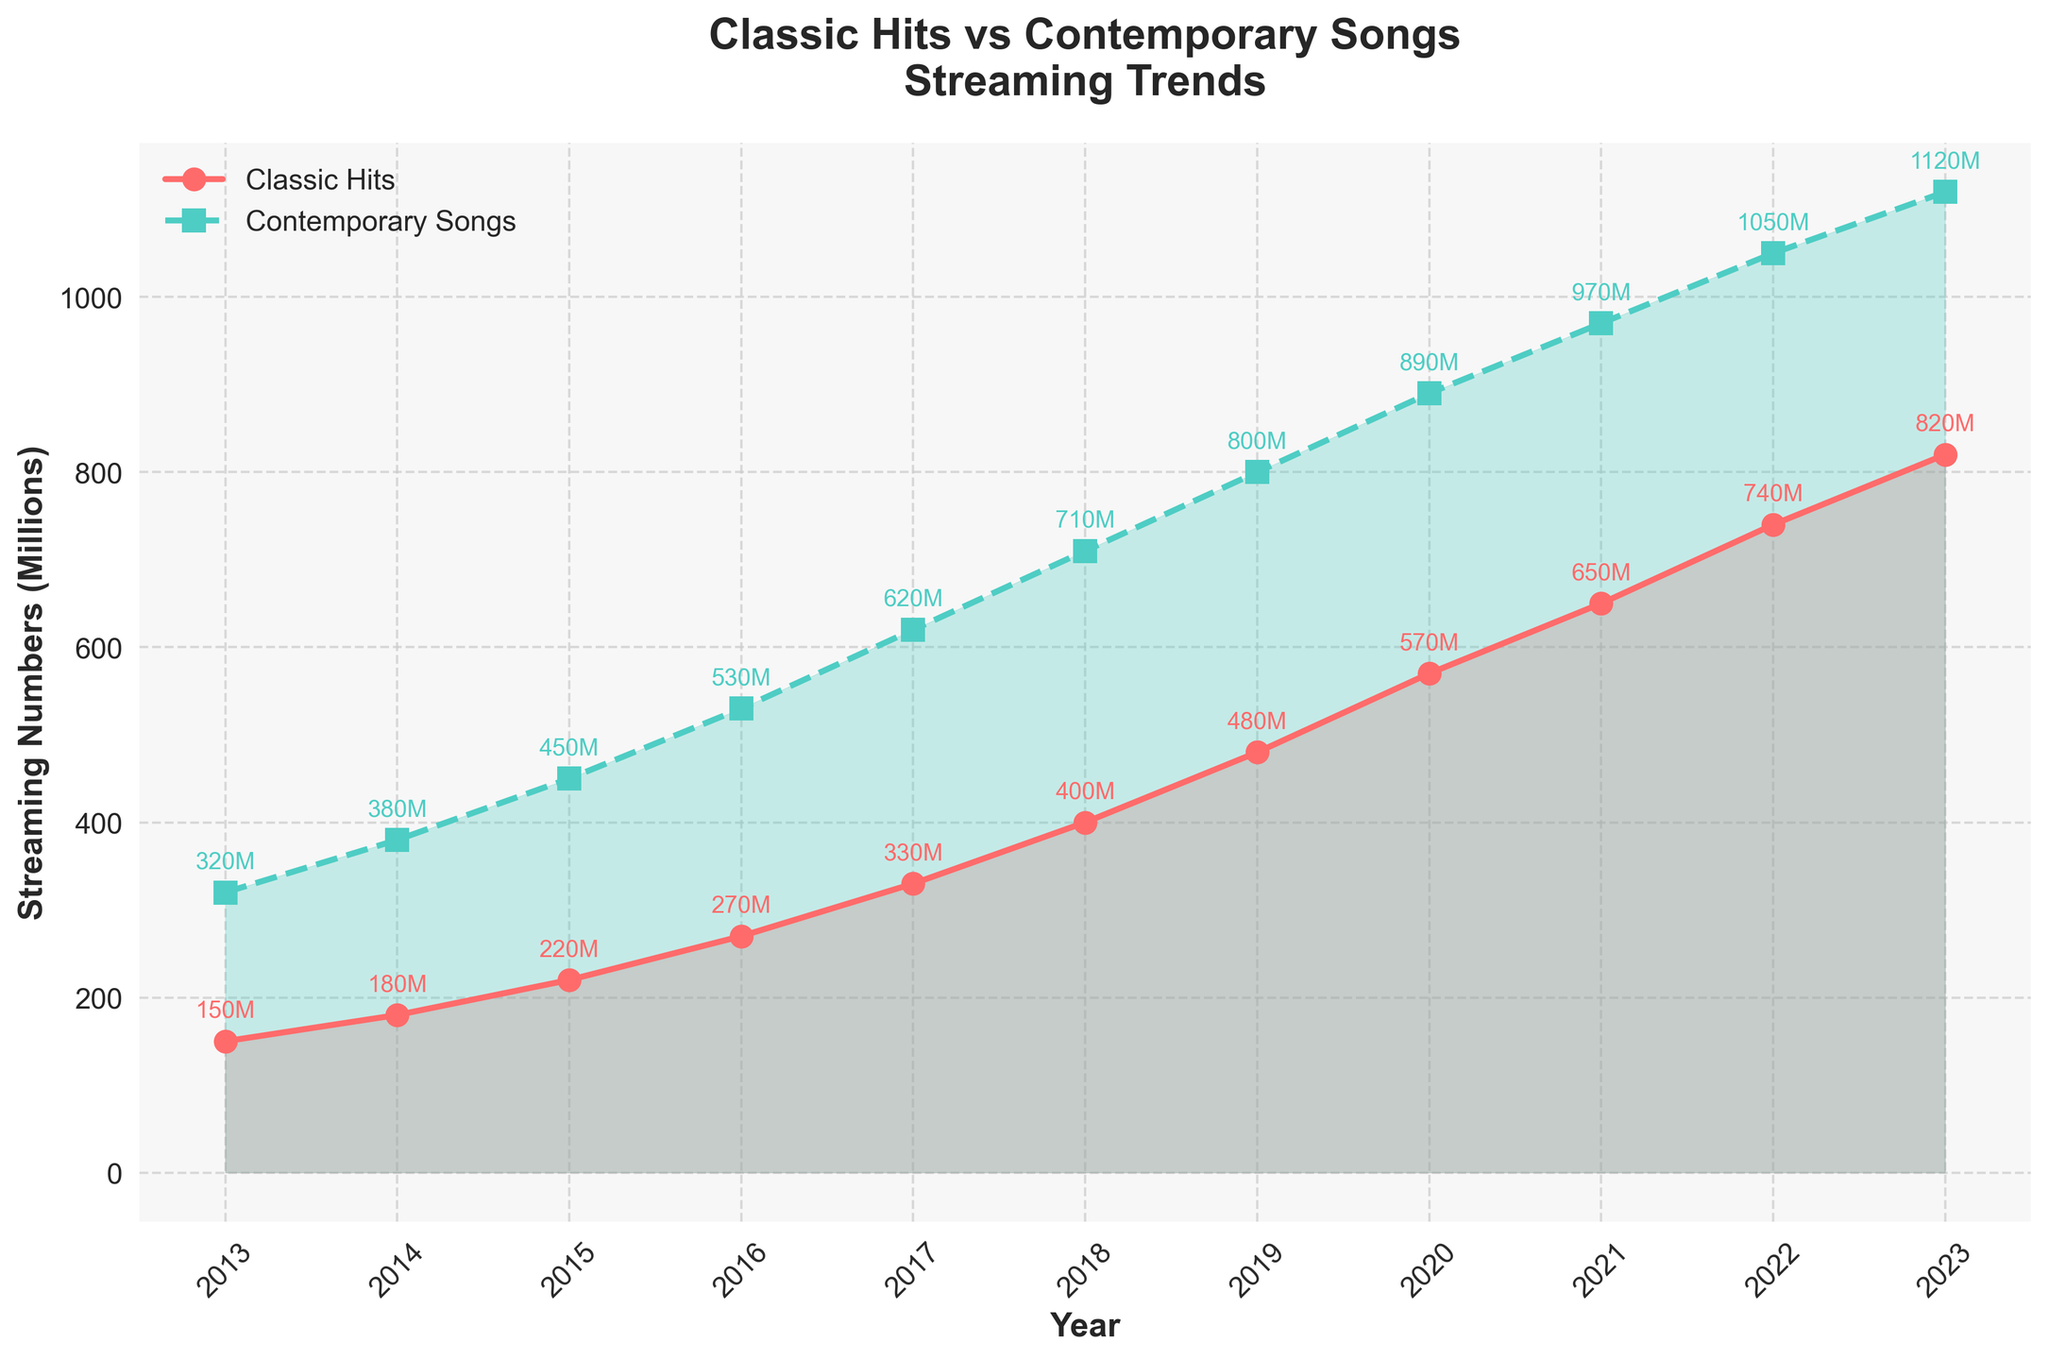Which year saw the highest streaming numbers for classic hits? Look for the peak value in the line representing classic hits. The highest value is in 2023, reaching 820 million.
Answer: 2023 How many more millions of streams did contemporary songs get than classic hits in 2018? Subtract the classic hits' value in 2018 from the contemporary songs' value in 2018. Contemporary songs had 710 million and classic hits had 400 million: 710 - 400 = 310 million.
Answer: 310 million What was the trend in streaming numbers for classic hits from 2013 to 2015? Examine the line for classic hits between 2013 and 2015. The numbers increased from 150 million in 2013 to 220 million in 2015, showing an upward trend.
Answer: Upward trend By how many millions did the streaming numbers for contemporary songs increase from 2017 to 2020? Subtract the value in 2017 from the value in 2020 for contemporary songs. The numbers increased from 620 million in 2017 to 890 million in 2020: 890 - 620 = 270 million.
Answer: 270 million Comparing the growth rate, did classic hits or contemporary songs grow faster from 2013 to 2023? Calculate and compare the growth rate for both. Classic hits grew from 150 million to 820 million (820 - 150 = 670 million), and contemporary songs grew from 320 million to 1120 million (1120 - 320 = 800 million). Despite streams being higher for contemporary songs, the rate of increase is steeper for classic hits.
Answer: Classic hits Which category of songs has more variability in their growth trend? Observe the lines representing classic hits and contemporary songs. The line for contemporary songs shows more significant, consistent increases, indicating less variability.
Answer: Classic hits Between which consecutive years did classic hits see the highest increase in streaming numbers? Look for the year with the steepest slope in the line for classic hits. The steepest slope is from 2019 to 2020, where the increase was 570 - 480 = 90 million.
Answer: 2019-2020 In 2023, what is the difference in streaming numbers between classic hits and contemporary songs? Subtract the numbers for classic hits from contemporary songs in 2023. Contemporary songs had 1120 million streams and classic hits had 820 million: 1120 - 820 = 300 million.
Answer: 300 million What is the average annual increase in streaming numbers for contemporary songs from 2013 to 2023? Calculate the total increase divided by the number of years. The total increase is 1120 - 320 = 800 million over 10 years, so the average increase is 800/10 = 80 million per year.
Answer: 80 million per year 